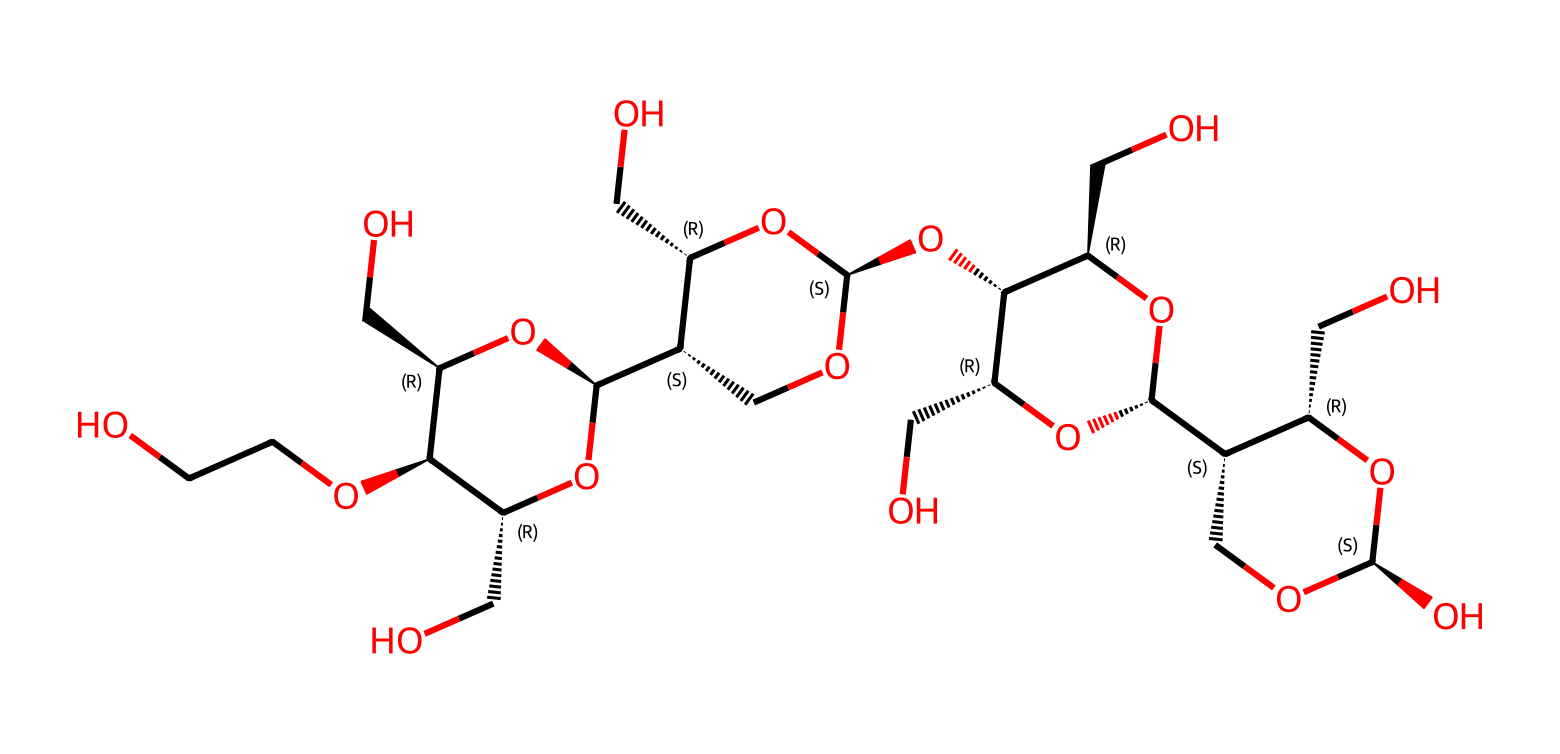What is the primary functional group present in this molecule? The structure contains multiple hydroxyl (-OH) groups, which are characteristic of alcohols. By examining the molecular arrangement, we can identify that each repeating unit has hydroxyl groups attached to the carbon backbone.
Answer: hydroxyl group How many cyclic structures are evident in this chemical? By analyzing the structure, we can count the rings formed by the arrangement of carbon and oxygen atoms. There are three distinct cycles in the molecule's structure.
Answer: three What type of polymer is represented by this structure? The molecule represents a polysaccharide due to its repeating units of sugar monomers (carbohydrate elements) linked together, which is typical of polymers.
Answer: polysaccharide What property of this molecule contributes to its classification as a Boger fluid? The structure's ability to remain viscous while exhibiting non-Newtonian characteristics arises from the significant molecular weight and the long polymer chains of polyethylene oxide, allowing it to respond to shear stress efficiently.
Answer: viscosity How many oxygen atoms are present in this molecule? By examining the structure, we can tally the oxygen atoms throughout the molecule. Counting the oxygen atoms yields a total of 10.
Answer: ten What aspect of the molecular architecture contributes to viscoelasticity in this compound? The viscoelastic behavior arises from the flexible polymer chain interactions along with the complexity of the molecular arrangement, allowing for both elastic and viscous responses to mechanical stress. These characteristics are confirmed through structural observation and attributes of linear polymer chains.
Answer: flexible polymer chains 